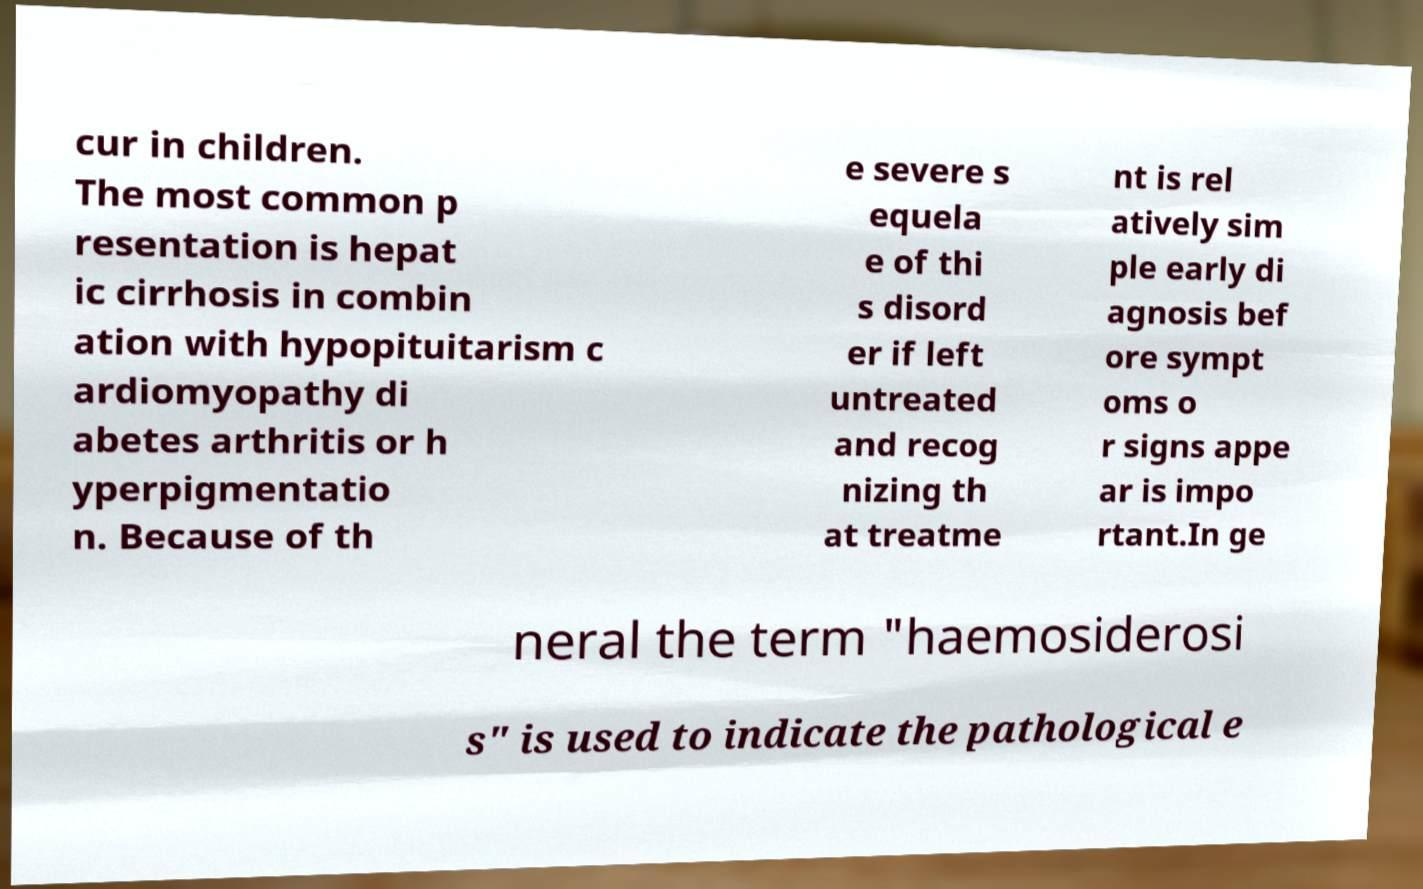I need the written content from this picture converted into text. Can you do that? cur in children. The most common p resentation is hepat ic cirrhosis in combin ation with hypopituitarism c ardiomyopathy di abetes arthritis or h yperpigmentatio n. Because of th e severe s equela e of thi s disord er if left untreated and recog nizing th at treatme nt is rel atively sim ple early di agnosis bef ore sympt oms o r signs appe ar is impo rtant.In ge neral the term "haemosiderosi s" is used to indicate the pathological e 